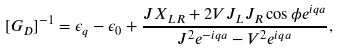Convert formula to latex. <formula><loc_0><loc_0><loc_500><loc_500>[ G _ { D } ] ^ { - 1 } = \epsilon _ { q } - \epsilon _ { 0 } + \frac { J X _ { L R } + 2 V J _ { L } J _ { R } \cos \phi e ^ { i q a } } { J ^ { 2 } e ^ { - i q a } - V ^ { 2 } e ^ { i q a } } ,</formula> 